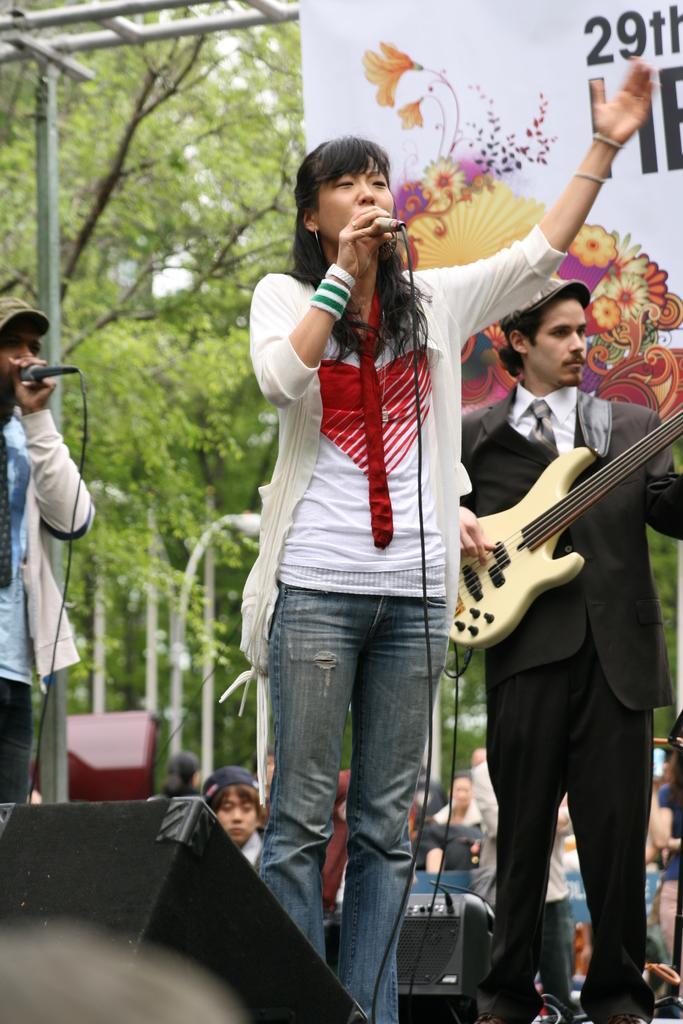Describe this image in one or two sentences. There is a woman standing in the center and she is singing on a microphone. Here we can see a person standing on the right side and he is playing on a guitar. Here we can see a man on the left side and he is also singing on a microphone. In the background we can see trees and this is looking like a hoarding. 